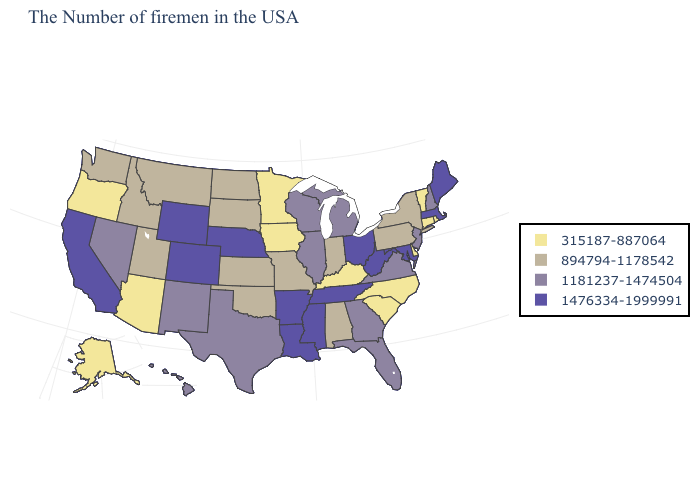Name the states that have a value in the range 315187-887064?
Short answer required. Rhode Island, Vermont, Connecticut, Delaware, North Carolina, South Carolina, Kentucky, Minnesota, Iowa, Arizona, Oregon, Alaska. Name the states that have a value in the range 1476334-1999991?
Concise answer only. Maine, Massachusetts, Maryland, West Virginia, Ohio, Tennessee, Mississippi, Louisiana, Arkansas, Nebraska, Wyoming, Colorado, California. Is the legend a continuous bar?
Keep it brief. No. Among the states that border Missouri , does Kentucky have the highest value?
Concise answer only. No. What is the highest value in the USA?
Quick response, please. 1476334-1999991. Name the states that have a value in the range 894794-1178542?
Short answer required. New York, Pennsylvania, Indiana, Alabama, Missouri, Kansas, Oklahoma, South Dakota, North Dakota, Utah, Montana, Idaho, Washington. What is the lowest value in the MidWest?
Answer briefly. 315187-887064. Which states hav the highest value in the South?
Keep it brief. Maryland, West Virginia, Tennessee, Mississippi, Louisiana, Arkansas. Among the states that border Pennsylvania , which have the lowest value?
Be succinct. Delaware. What is the value of Tennessee?
Write a very short answer. 1476334-1999991. What is the value of West Virginia?
Keep it brief. 1476334-1999991. Among the states that border Arkansas , which have the highest value?
Give a very brief answer. Tennessee, Mississippi, Louisiana. What is the value of New York?
Concise answer only. 894794-1178542. Does Idaho have the lowest value in the USA?
Concise answer only. No. What is the value of Indiana?
Answer briefly. 894794-1178542. 